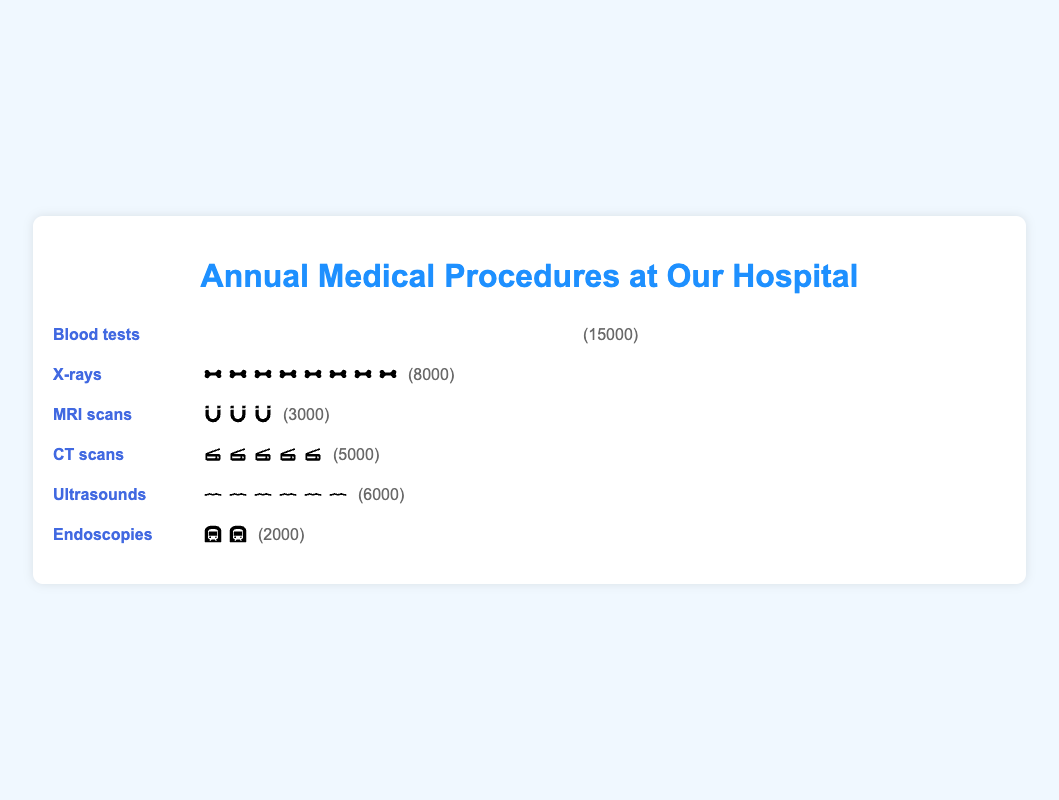What's the title of the figure? The title of the figure is displayed prominently at the top, and it reads "Annual Medical Procedures at Our Hospital".
Answer: Annual Medical Procedures at Our Hospital Which medical procedure is performed the most frequently? The frequency of each procedure is visually represented by the number of icons and the count. Blood tests have the highest count of 15,000, making it the most frequently performed procedure.
Answer: Blood tests What is the count of MRI scans? The count for MRI scans is displayed next to the visual representation of icons. The text shows (3000) next to the MRI scans section.
Answer: 3000 What is the total count for X-rays and CT scans combined? The count for each procedure is shown next to the visual representation. X-rays have a count of 8000, and CT scans have a count of 5000. Adding these gives 8000 + 5000 = 13000.
Answer: 13000 How does the frequency of ultrasounds compare to the frequency of endoscopies? Compare the counts displayed next to the visual representation of each procedure. Ultrasounds have a count of 6000, while endoscopies have a count of 2000. 6000 is greater than 2000.
Answer: Ultrasounds are performed more frequently than endoscopies Which procedure has more icons, MRI scans or CT scans? The visual representation for each procedure shows a number of icons. The number of icons corresponds to the count divided by 1000 (with a max of 15). MRI scans have 3000, resulting in 3 icons; CT scans have 5000, resulting in 5 icons. Therefore, CT scans have more icons.
Answer: CT scans What is the range of procedure counts represented in the figure? The range is calculated as the difference between the maximum and minimum counts. The maximum count is for blood tests (15,000) and the minimum count is for endoscopies (2000). The range is 15000 - 2000 = 13000.
Answer: 13000 Which procedure has the least number of icons? The number of icons corresponds to the count divided by 1000 (with a max of 15). Endoscopies have the least number of icons with 2, since their count is 2000.
Answer: Endoscopies What is the average count of all the procedures? The average is calculated by summing the counts of all procedures and dividing by the number of procedures. The counts are 15000, 8000, 3000, 5000, 6000, and 2000. Sum = 15000 + 8000 + 3000 + 5000 + 6000 + 2000 = 39000. There are 6 procedures, so the average is 39000 / 6 = 6500.
Answer: 6500 How many more blood tests are there than MRI scans? The difference between the counts of blood tests and MRI scans is calculated. Blood tests have 15000 and MRI scans have 3000. The difference is 15000 - 3000 = 12000.
Answer: 12000 